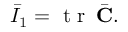Convert formula to latex. <formula><loc_0><loc_0><loc_500><loc_500>\bar { I } _ { 1 } = t r \, \bar { C } .</formula> 